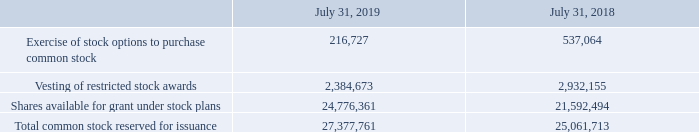Common Stock Reserved for Issuance
As of July 31, 2019 and 2018, the Company was authorized to issue 500,000,000 shares of common stock with a par value of $0.0001 per share and, of these, 82,140,883 and 80,611,698 shares of common stock were issued and outstanding, respectively. Per the terms of the Company’s 2011 Stock Plan, on January first of each year, an additional number of shares equal to up to 5% of the number of shares of common stock issued and outstanding on the preceding December 31st is added to the Company’s 2011 Stock Plan reserve.
As of July 31, 2019 and 2018, the Company had reserved shares of common stock for future issuance as follows:
In March 2018, the Company completed a public offering of 2,628,571 shares of its common stock. The public offering price of the shares sold in the offering was $87.50 per share. No shares were sold by the Company’s stockholders in this public offering.
How many shares was the company authorized to issue in 2019 and 2018? 500,000,000. What was the Exercise of stock options to purchase common stock in 2019 and 2018 respectively? 216,727, 537,064. What was the Vesting of restricted stock awards in 2019? 2,384,673. In which year was Exercise of stock options to purchase common stock less than 300,000? Locate and analyze exercise of stock options to purchase common stock in row 2
answer: 2019. What was the average Vesting of restricted stock awards for 2018 and 2019? (2,384,673 + 2,932,155) / 2
Answer: 2658414. What is the change in the Shares available for grant under stock plans from 2018 to 2019? 24,776,361 - 21,592,494
Answer: 3183867. 